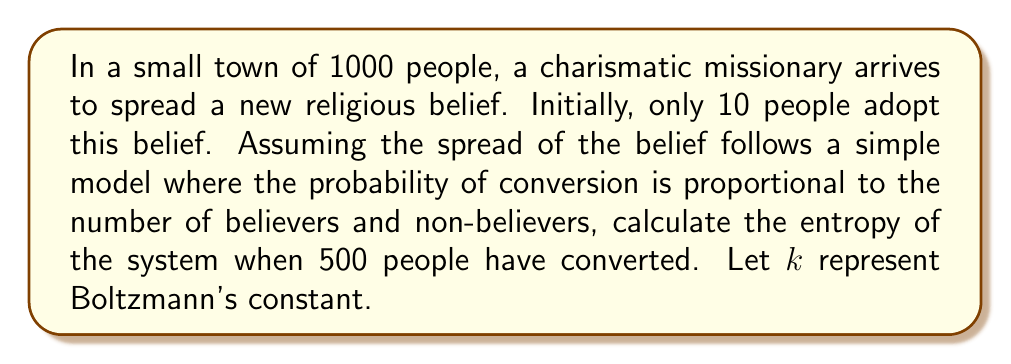Help me with this question. Let's approach this step-by-step:

1) In statistical mechanics, entropy is often calculated using the formula:

   $$S = k \ln W$$

   Where $S$ is entropy, $k$ is Boltzmann's constant, and $W$ is the number of microstates.

2) In this case, we can consider each person as having two possible states: believer or non-believer. The number of microstates is the number of ways to arrange 500 believers among 1000 people.

3) This is equivalent to choosing 500 people out of 1000, which is given by the combination formula:

   $$W = \binom{1000}{500} = \frac{1000!}{500!(1000-500)!} = \frac{1000!}{500!500!}$$

4) Calculating this exactly would result in a very large number. Instead, we can use Stirling's approximation for factorials:

   $$\ln(n!) \approx n \ln(n) - n$$

5) Applying this to our formula:

   $$\begin{align}
   S &= k \ln\left(\frac{1000!}{500!500!}\right) \\
   &= k[\ln(1000!) - \ln(500!) - \ln(500!)] \\
   &\approx k[(1000\ln(1000) - 1000) - 2(500\ln(500) - 500)] \\
   &= k[1000\ln(1000) - 1000 - 1000\ln(500) + 1000] \\
   &= 1000k[\ln(1000) - \ln(500)] \\
   &= 1000k \ln(2) \\
   &= 1000k \cdot 0.69314718
   \end{align}$$

6) The final result is approximately $693.14718k$.

This result shows that the system is at its maximum entropy when the belief is spread to exactly half the population, reflecting the greatest uncertainty about an individual's belief state.
Answer: $693.14718k$ 